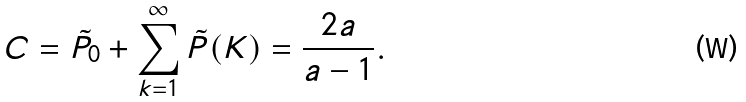Convert formula to latex. <formula><loc_0><loc_0><loc_500><loc_500>C = \tilde { P } _ { 0 } + \sum _ { k = 1 } ^ { \infty } \tilde { P } ( K ) = \frac { 2 a } { a - 1 } .</formula> 